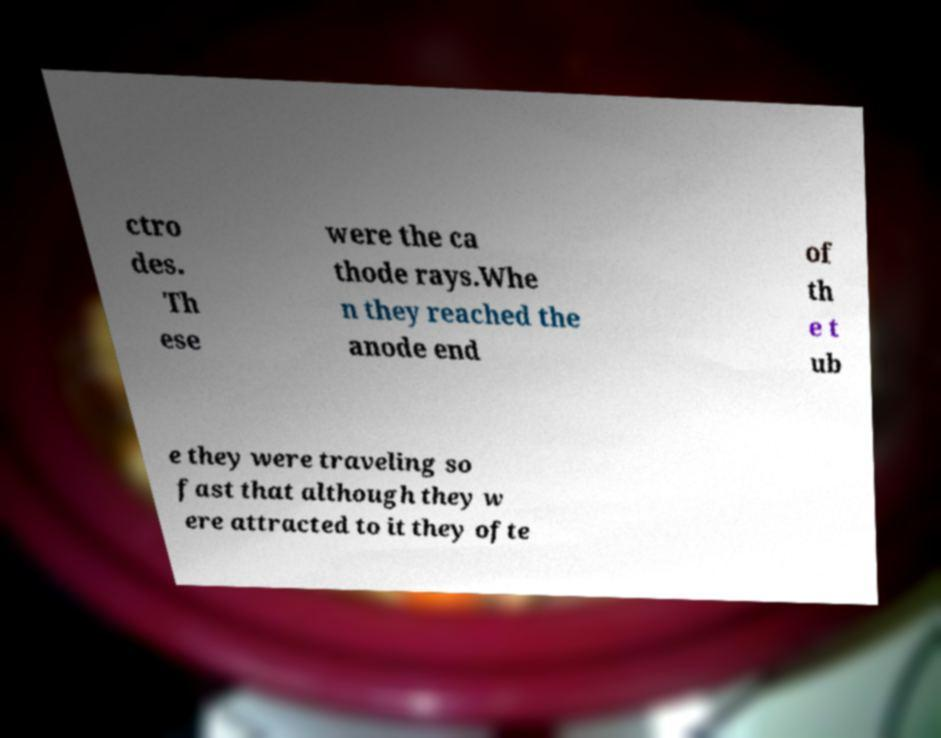For documentation purposes, I need the text within this image transcribed. Could you provide that? ctro des. Th ese were the ca thode rays.Whe n they reached the anode end of th e t ub e they were traveling so fast that although they w ere attracted to it they ofte 